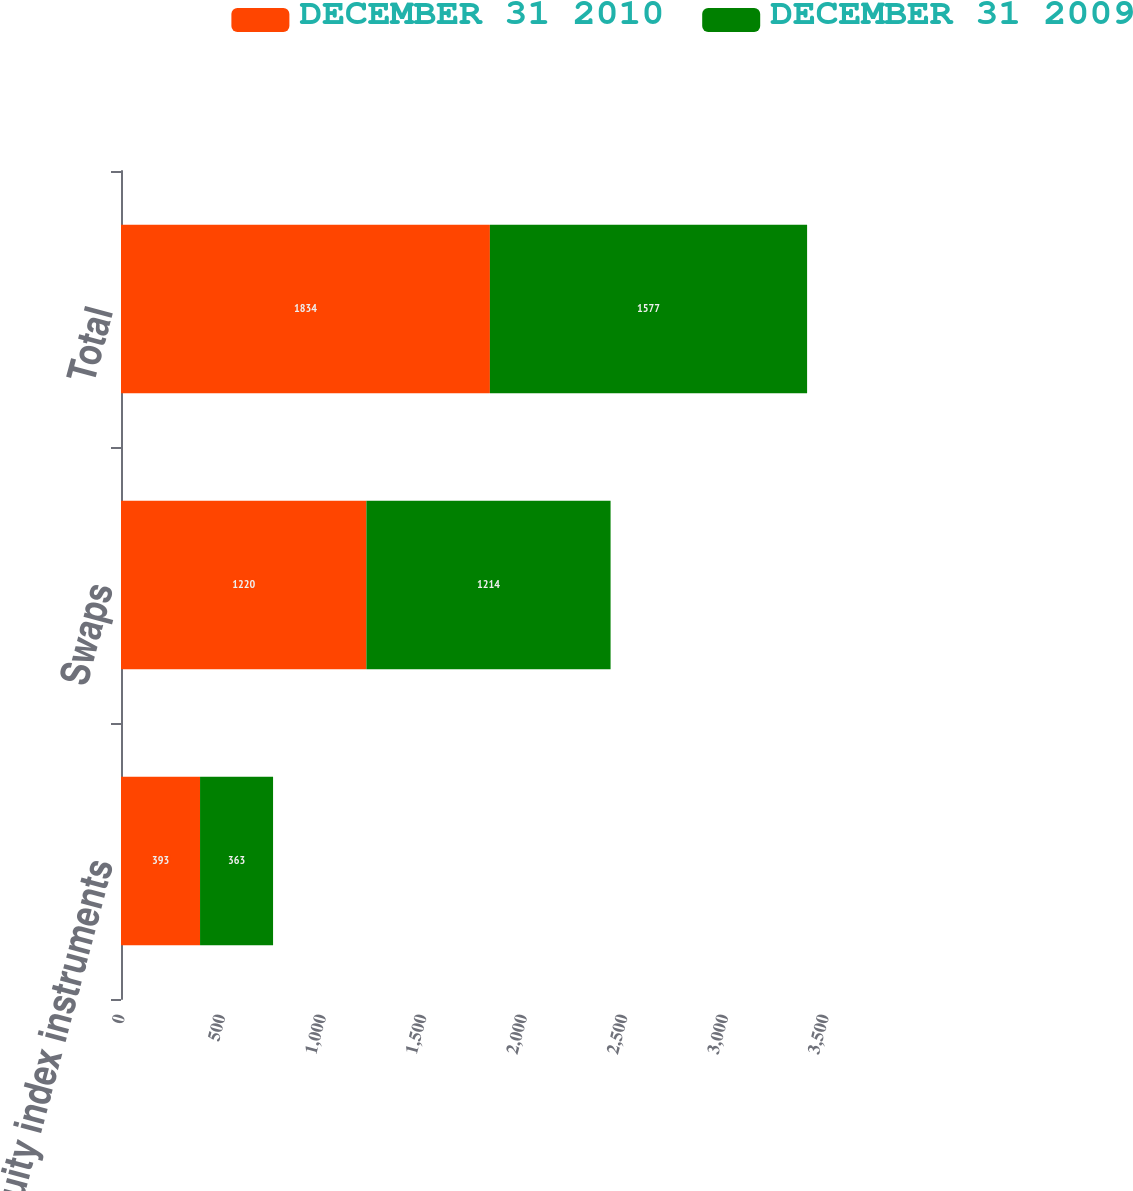Convert chart. <chart><loc_0><loc_0><loc_500><loc_500><stacked_bar_chart><ecel><fcel>Equity index instruments<fcel>Swaps<fcel>Total<nl><fcel>DECEMBER 31 2010<fcel>393<fcel>1220<fcel>1834<nl><fcel>DECEMBER 31 2009<fcel>363<fcel>1214<fcel>1577<nl></chart> 